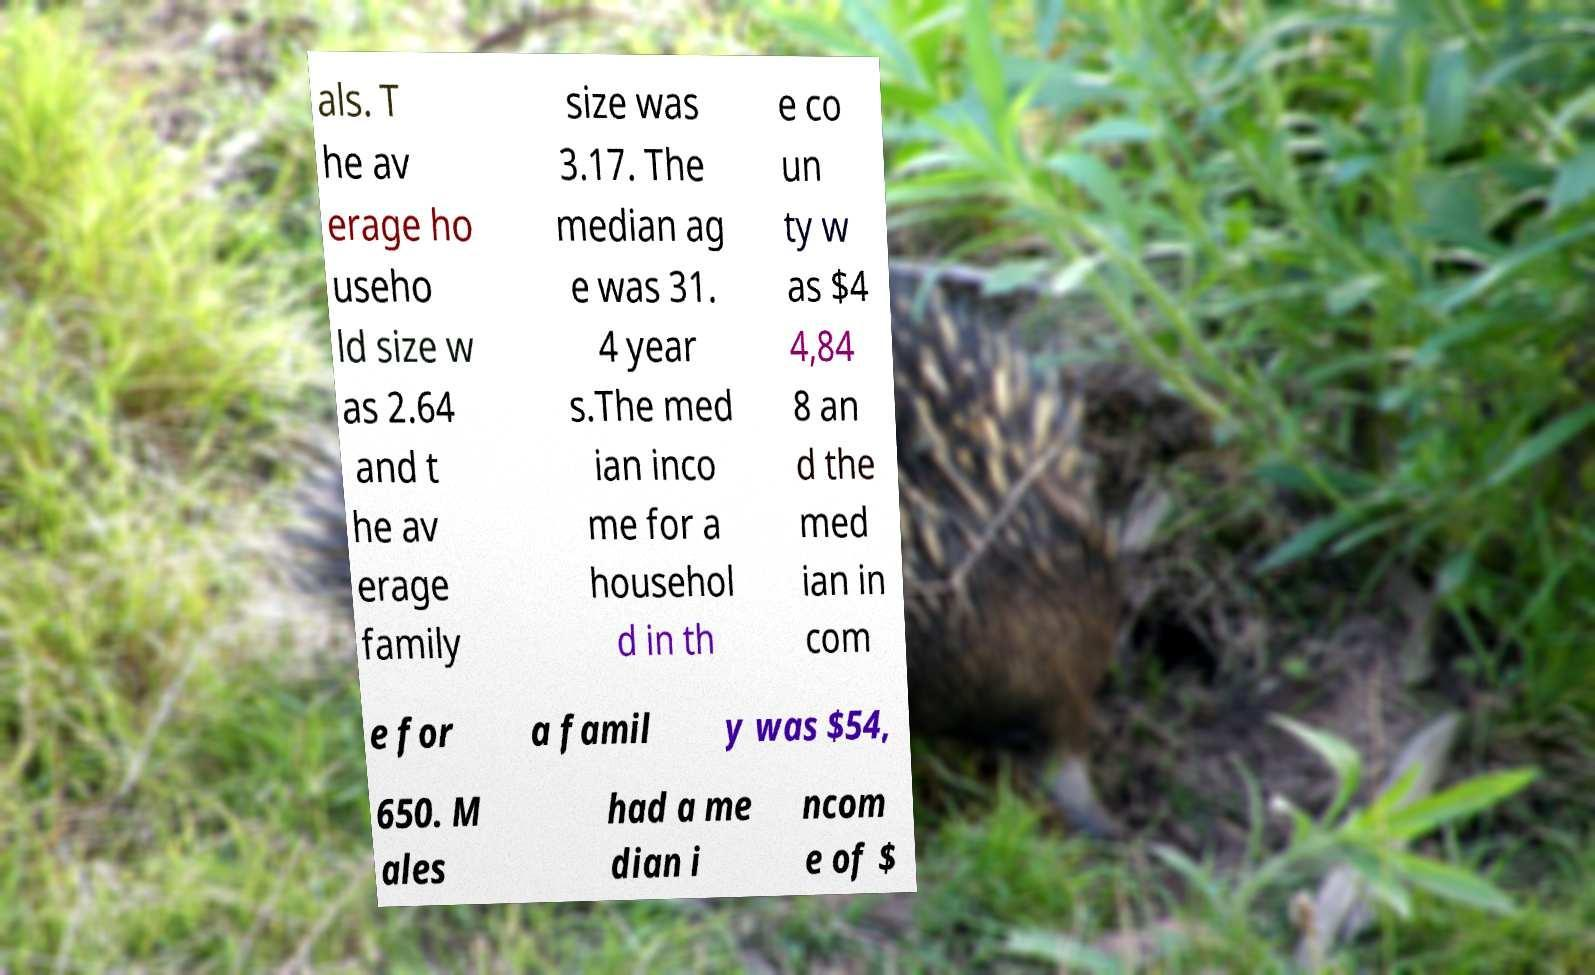Please read and relay the text visible in this image. What does it say? als. T he av erage ho useho ld size w as 2.64 and t he av erage family size was 3.17. The median ag e was 31. 4 year s.The med ian inco me for a househol d in th e co un ty w as $4 4,84 8 an d the med ian in com e for a famil y was $54, 650. M ales had a me dian i ncom e of $ 